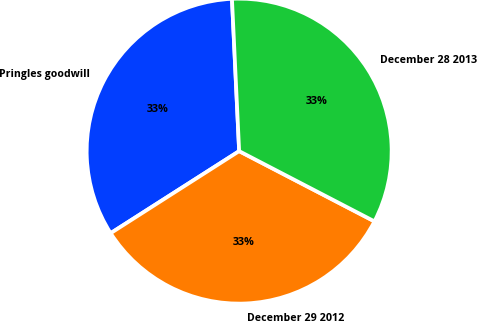<chart> <loc_0><loc_0><loc_500><loc_500><pie_chart><fcel>Pringles goodwill<fcel>December 29 2012<fcel>December 28 2013<nl><fcel>33.29%<fcel>33.33%<fcel>33.37%<nl></chart> 